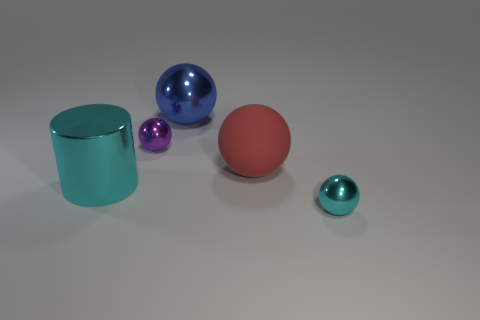Add 1 cyan matte cylinders. How many objects exist? 6 Subtract all spheres. How many objects are left? 1 Subtract all cyan balls. How many balls are left? 3 Add 3 blue metal spheres. How many blue metal spheres are left? 4 Add 1 balls. How many balls exist? 5 Subtract all blue spheres. How many spheres are left? 3 Subtract 0 blue cubes. How many objects are left? 5 Subtract 1 cylinders. How many cylinders are left? 0 Subtract all gray spheres. Subtract all red blocks. How many spheres are left? 4 Subtract all gray cylinders. How many blue balls are left? 1 